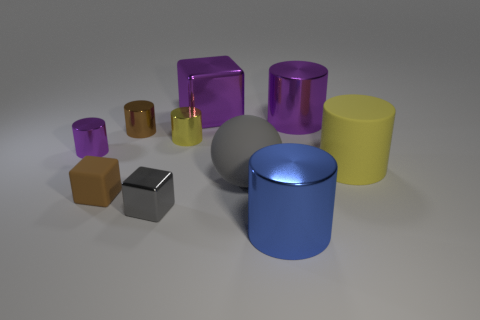There is a large purple metallic thing that is right of the large block; is its shape the same as the big purple metal object on the left side of the big matte sphere?
Give a very brief answer. No. Are there any purple blocks?
Provide a short and direct response. Yes. There is a large thing that is the same color as the tiny metallic block; what is it made of?
Keep it short and to the point. Rubber. What number of objects are either green rubber objects or small rubber objects?
Give a very brief answer. 1. Is there a tiny block of the same color as the rubber sphere?
Make the answer very short. Yes. There is a yellow object that is behind the large yellow rubber cylinder; how many shiny things are in front of it?
Offer a terse response. 3. Is the number of tiny matte cubes greater than the number of brown objects?
Provide a succinct answer. No. Does the large block have the same material as the large yellow cylinder?
Ensure brevity in your answer.  No. Are there the same number of tiny gray cubes in front of the tiny shiny block and red rubber things?
Provide a short and direct response. Yes. How many purple cylinders are the same material as the gray block?
Your answer should be compact. 2. 